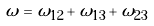Convert formula to latex. <formula><loc_0><loc_0><loc_500><loc_500>\omega = \omega _ { 1 2 } + \omega _ { 1 3 } + \omega _ { 2 3 }</formula> 